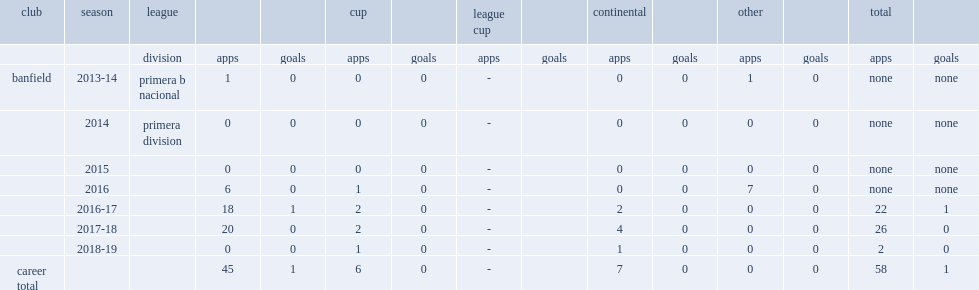Which league did sporle make his debut in 2013-14 with banfield? Primera b nacional. 